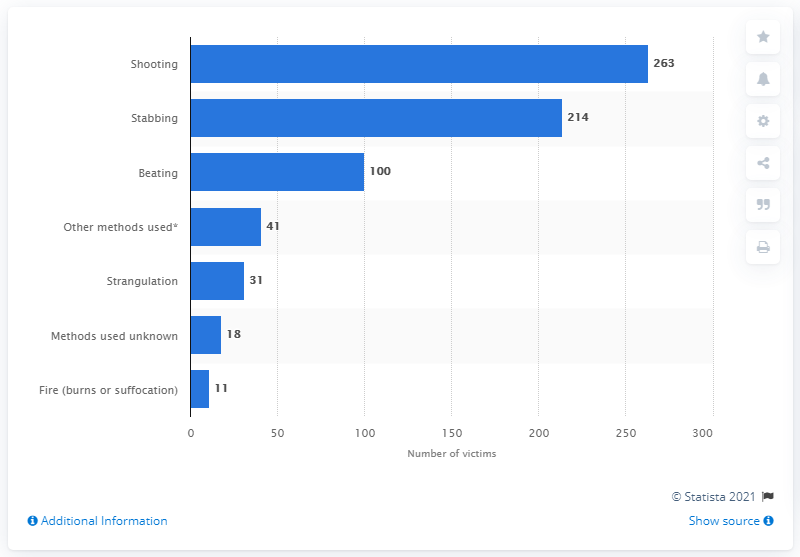Outline some significant characteristics in this image. The homicide involving 100 victims is a beating. In 2019, there were 477 homicides that were caused by stabbing and shooting. 